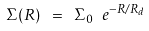Convert formula to latex. <formula><loc_0><loc_0><loc_500><loc_500>\Sigma ( R ) \ = \ \Sigma _ { 0 } \ e ^ { - R / R _ { d } }</formula> 